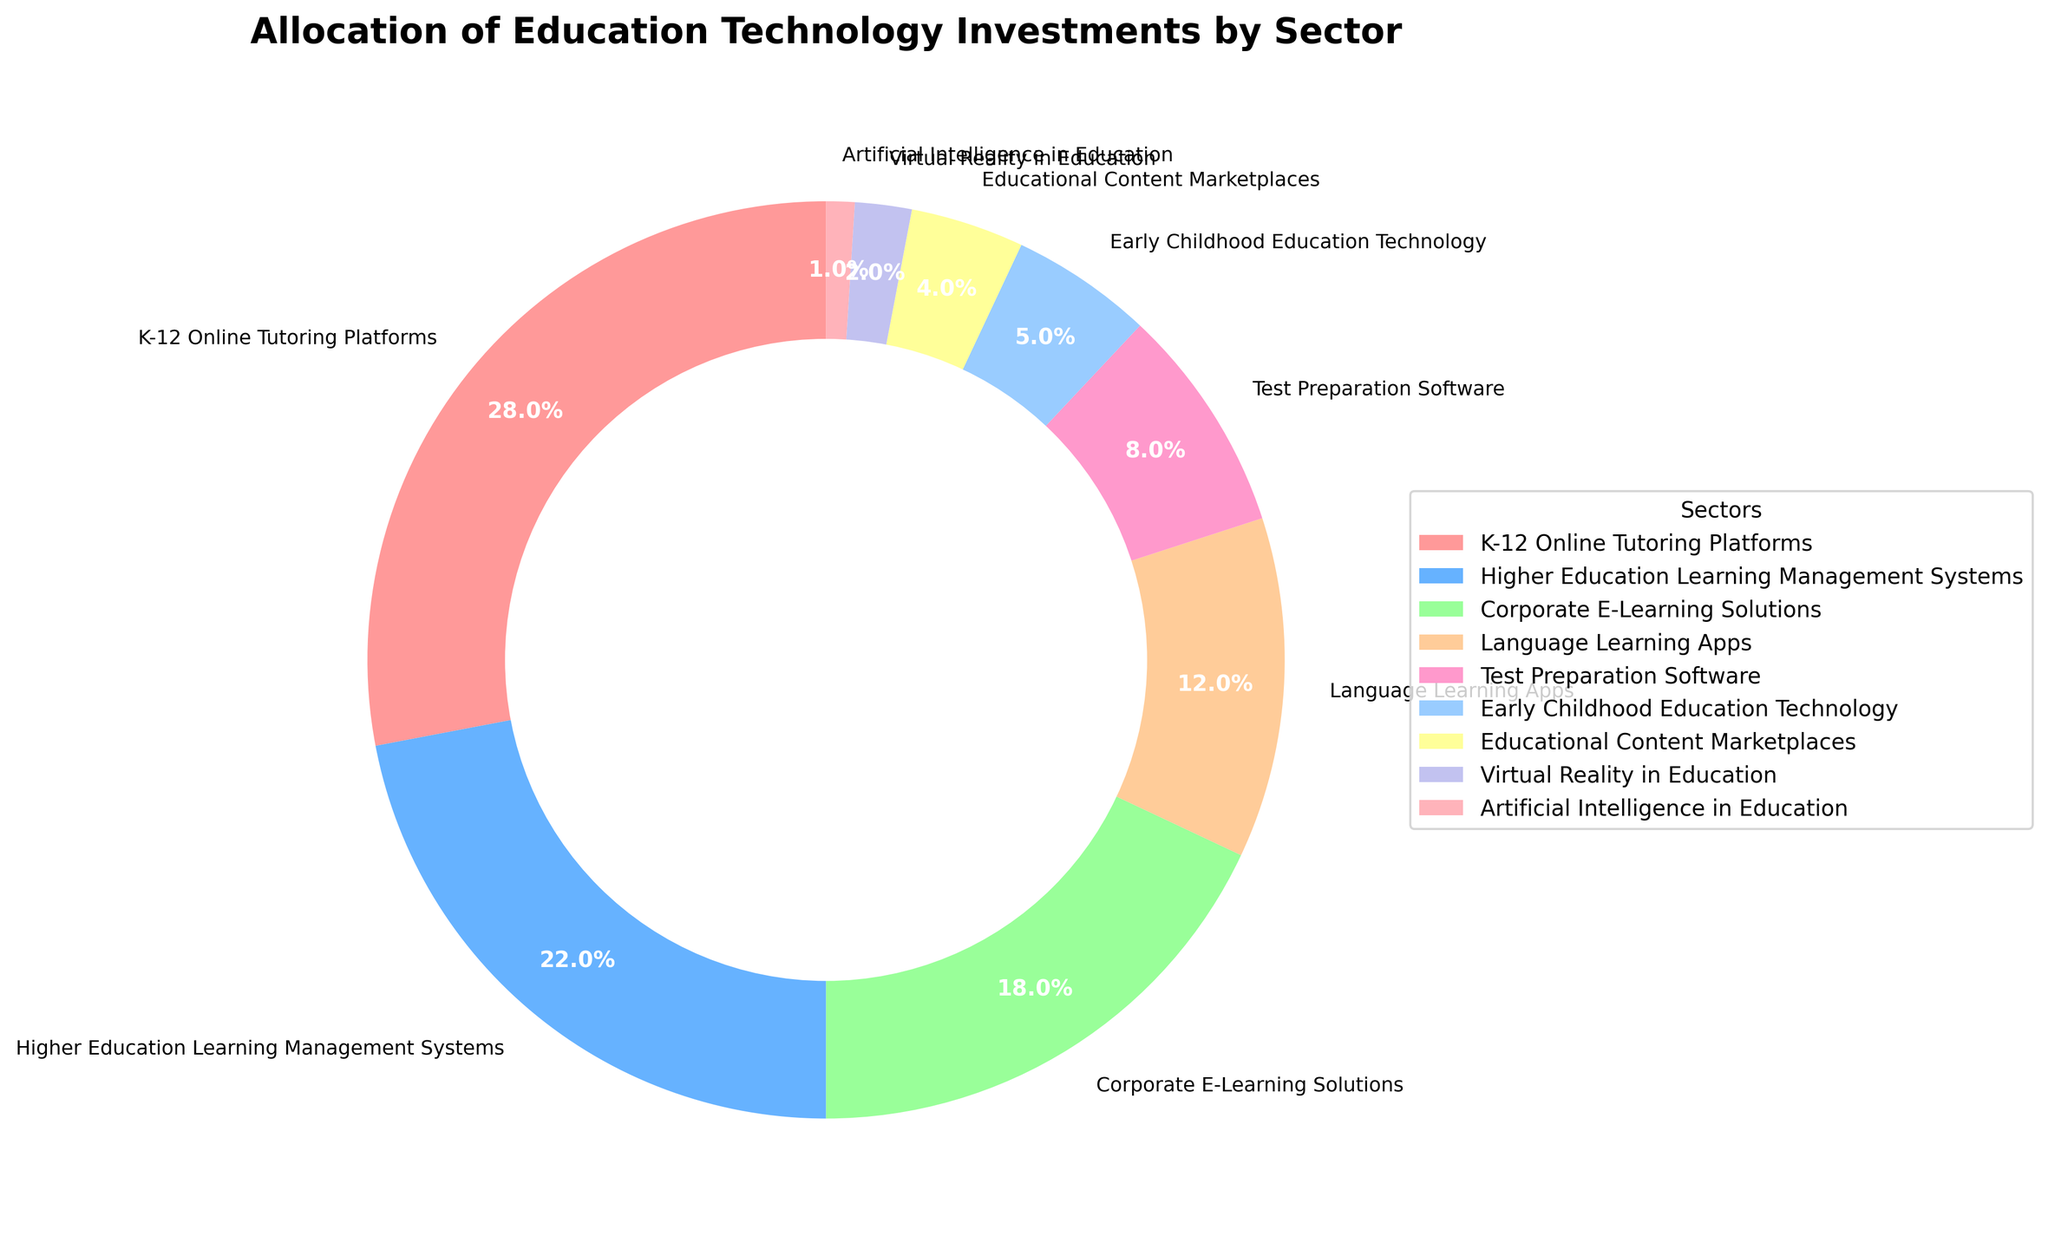What is the sector with the highest investment percentage? The sector with the highest investment percentage can be identified by looking at the largest slice of the pie chart. The largest slice is labeled "K-12 Online Tutoring Platforms" with 28%.
Answer: K-12 Online Tutoring Platforms Which sector has the lowest investment percentage? The smallest slice on the pie chart represents the sector with the lowest investment percentage. This slice is labeled "Artificial Intelligence in Education" with 1%.
Answer: Artificial Intelligence in Education How much more is invested in K-12 Online Tutoring Platforms compared to Virtual Reality in Education? To find how much more is invested, subtract the investment percentage of Virtual Reality in Education (2%) from K-12 Online Tutoring Platforms (28%): 28% - 2% = 26%.
Answer: 26% What is the combined investment percentage for Language Learning Apps and Test Preparation Software? Add the investment percentages of Language Learning Apps (12%) and Test Preparation Software (8%): 12% + 8% = 20%.
Answer: 20% Which investment sector is represented by the red color in the chart? By visually identifying the red-colored slice on the chart, we can see that it corresponds to "K-12 Online Tutoring Platforms".
Answer: K-12 Online Tutoring Platforms How much more is invested in Higher Education Learning Management Systems compared to Early Childhood Education Technology? Subtract the investment percentage of Early Childhood Education Technology (5%) from Higher Education Learning Management Systems (22%): 22% - 5% = 17%.
Answer: 17% Is the investment percentage for Corporate E-Learning Solutions greater than the combined investment percentages of Virtual Reality in Education and Artificial Intelligence in Education? First, sum the percentages of Virtual Reality in Education (2%) and Artificial Intelligence in Education (1%): 2% + 1% = 3%. Compare this sum with Corporate E-Learning Solutions (18%). Yes, 18% is greater than 3%.
Answer: Yes What sectors combined make up exactly half of the total investment? To find two sectors that make up half of the total investment, ensure their combined percentage is 50%. Combining K-12 Online Tutoring Platforms (28%) and Higher Education Learning Management Systems (22%) results in 28% + 22% = 50%.
Answer: K-12 Online Tutoring Platforms and Higher Education Learning Management Systems Which sector receives almost double the investment of Educational Content Marketplaces? Identify the sector whose investment is nearly twice that of Educational Content Marketplaces (4%). Test Preparation Software, with an investment of 8%, is almost double 4%.
Answer: Test Preparation Software 